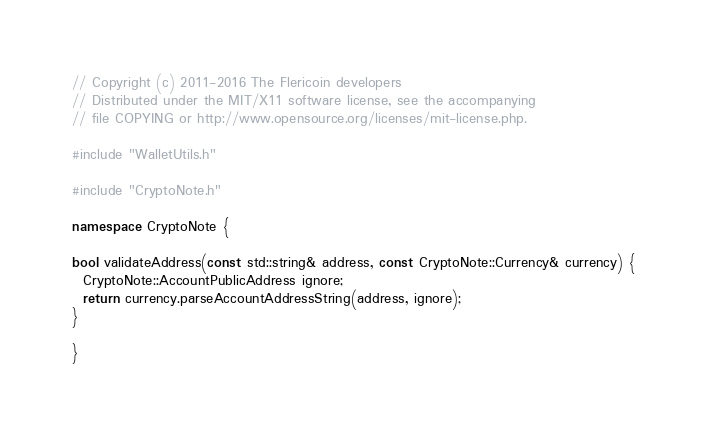Convert code to text. <code><loc_0><loc_0><loc_500><loc_500><_C++_>// Copyright (c) 2011-2016 The Flericoin developers
// Distributed under the MIT/X11 software license, see the accompanying
// file COPYING or http://www.opensource.org/licenses/mit-license.php.

#include "WalletUtils.h"

#include "CryptoNote.h"

namespace CryptoNote {

bool validateAddress(const std::string& address, const CryptoNote::Currency& currency) {
  CryptoNote::AccountPublicAddress ignore;
  return currency.parseAccountAddressString(address, ignore);
}

}
</code> 